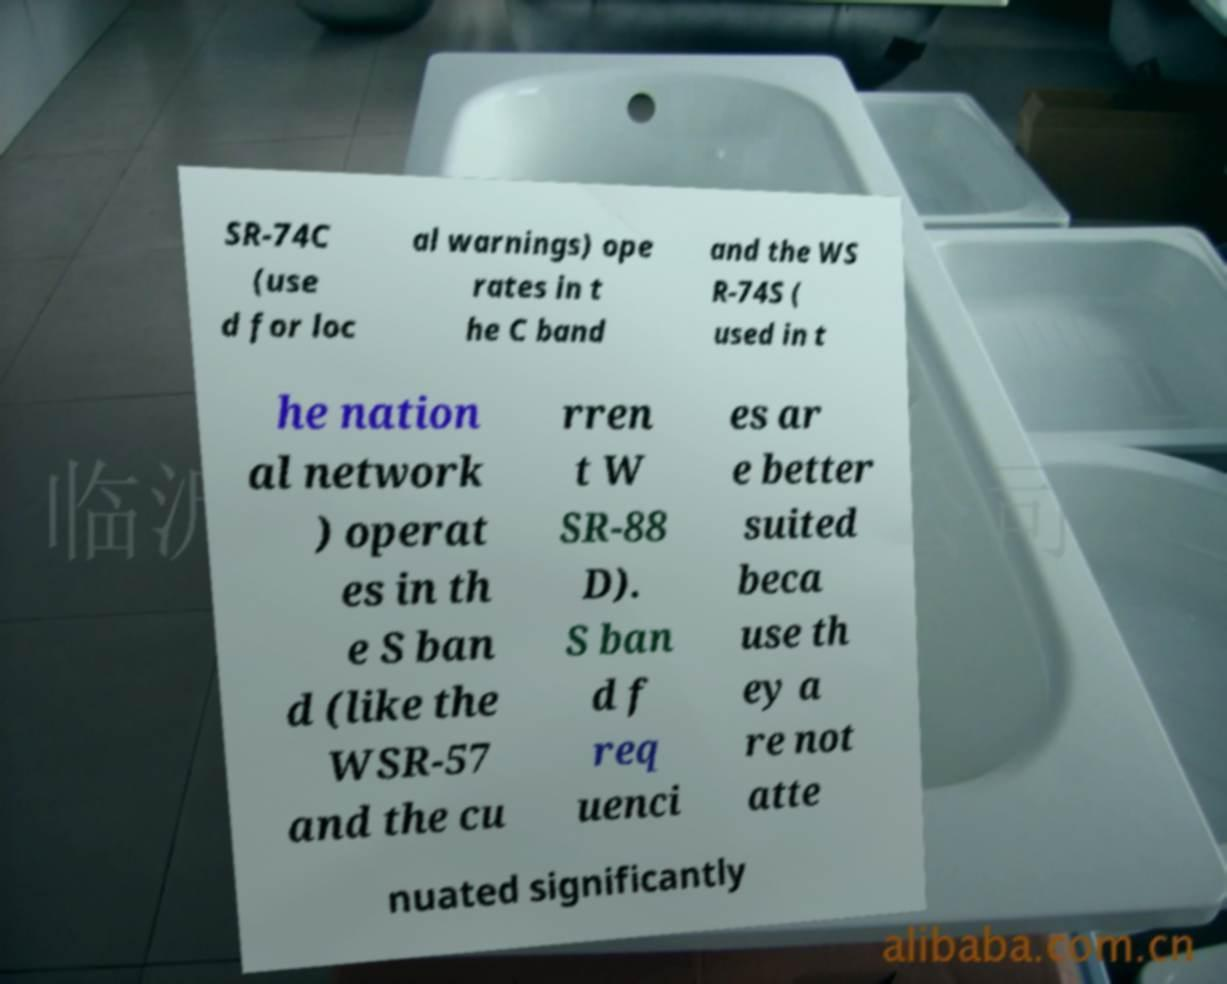What messages or text are displayed in this image? I need them in a readable, typed format. SR-74C (use d for loc al warnings) ope rates in t he C band and the WS R-74S ( used in t he nation al network ) operat es in th e S ban d (like the WSR-57 and the cu rren t W SR-88 D). S ban d f req uenci es ar e better suited beca use th ey a re not atte nuated significantly 